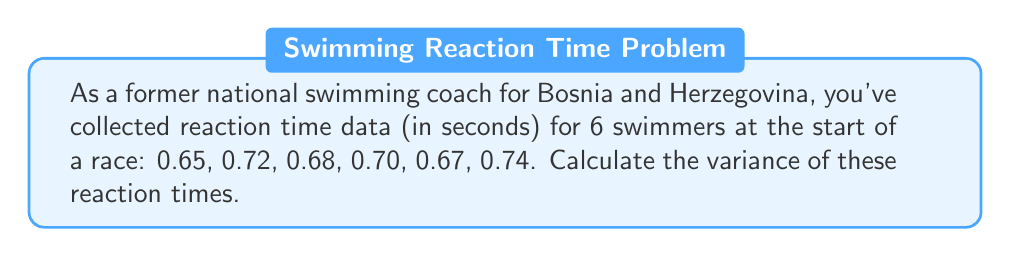Can you solve this math problem? To calculate the variance, we'll follow these steps:

1. Calculate the mean (μ) of the reaction times:
   $$ \mu = \frac{0.65 + 0.72 + 0.68 + 0.70 + 0.67 + 0.74}{6} = 0.6933 $$

2. Calculate the squared differences from the mean:
   $$ (0.65 - 0.6933)^2 = (-0.0433)^2 = 0.001875 $$
   $$ (0.72 - 0.6933)^2 = (0.0267)^2 = 0.000712 $$
   $$ (0.68 - 0.6933)^2 = (-0.0133)^2 = 0.000177 $$
   $$ (0.70 - 0.6933)^2 = (0.0067)^2 = 0.000045 $$
   $$ (0.67 - 0.6933)^2 = (-0.0233)^2 = 0.000543 $$
   $$ (0.74 - 0.6933)^2 = (0.0467)^2 = 0.002181 $$

3. Sum the squared differences:
   $$ 0.001875 + 0.000712 + 0.000177 + 0.000045 + 0.000543 + 0.002181 = 0.005533 $$

4. Divide by (n-1) = 5 to get the variance:
   $$ \text{Variance} = \frac{0.005533}{5} = 0.0011066 $$

Therefore, the variance of the reaction times is approximately 0.0011066 seconds squared.
Answer: $0.0011066 \text{ s}^2$ 